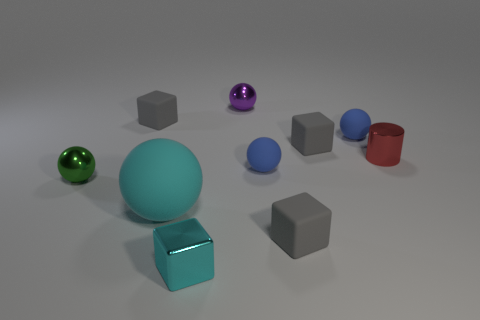Subtract all gray cubes. How many were subtracted if there are1gray cubes left? 2 Subtract all gray cubes. How many cubes are left? 1 Subtract all small metal cubes. How many cubes are left? 3 Subtract all cylinders. How many objects are left? 9 Subtract 1 blocks. How many blocks are left? 3 Subtract all green balls. Subtract all brown blocks. How many balls are left? 4 Subtract all red cubes. How many blue balls are left? 2 Subtract all metal blocks. Subtract all big cyan things. How many objects are left? 8 Add 7 small green objects. How many small green objects are left? 8 Add 4 tiny red metallic objects. How many tiny red metallic objects exist? 5 